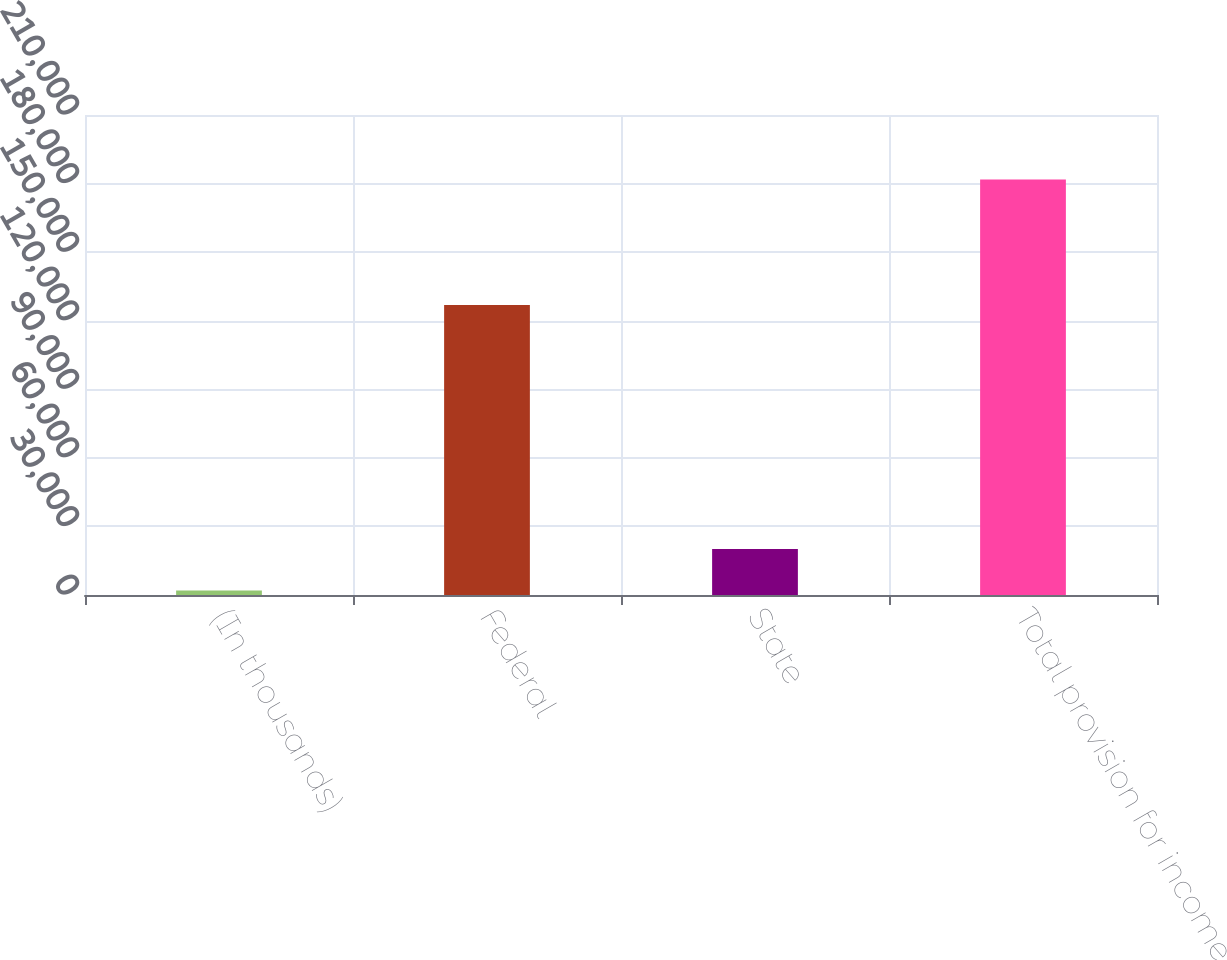<chart> <loc_0><loc_0><loc_500><loc_500><bar_chart><fcel>(In thousands)<fcel>Federal<fcel>State<fcel>Total provision for income<nl><fcel>2016<fcel>126903<fcel>20111<fcel>181822<nl></chart> 